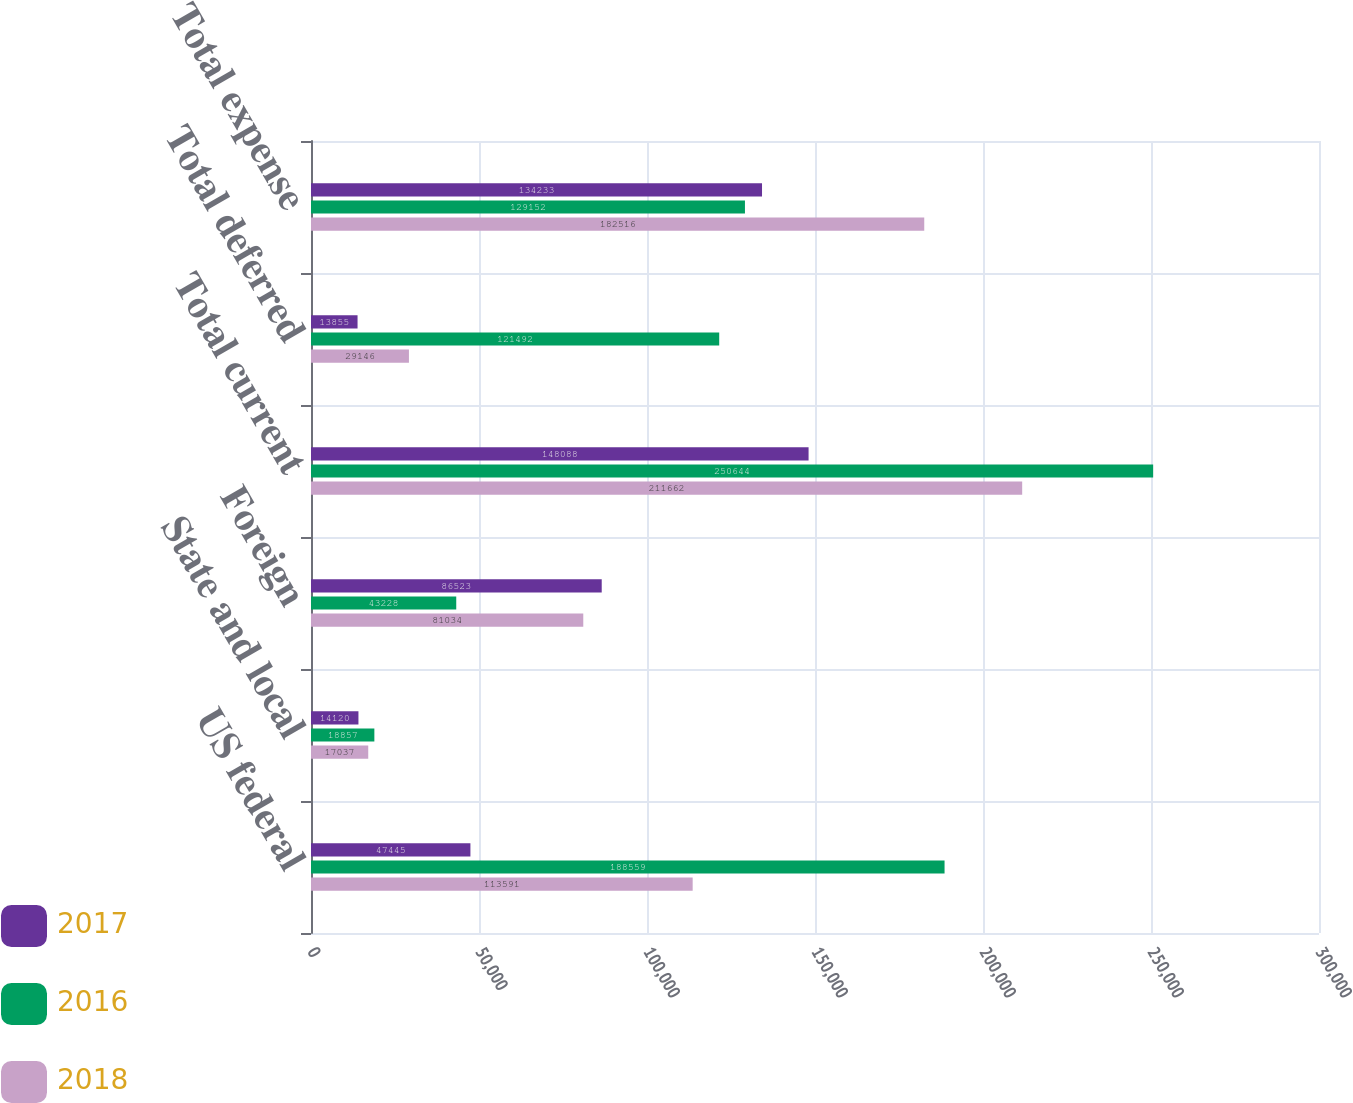Convert chart to OTSL. <chart><loc_0><loc_0><loc_500><loc_500><stacked_bar_chart><ecel><fcel>US federal<fcel>State and local<fcel>Foreign<fcel>Total current<fcel>Total deferred<fcel>Total expense<nl><fcel>2017<fcel>47445<fcel>14120<fcel>86523<fcel>148088<fcel>13855<fcel>134233<nl><fcel>2016<fcel>188559<fcel>18857<fcel>43228<fcel>250644<fcel>121492<fcel>129152<nl><fcel>2018<fcel>113591<fcel>17037<fcel>81034<fcel>211662<fcel>29146<fcel>182516<nl></chart> 